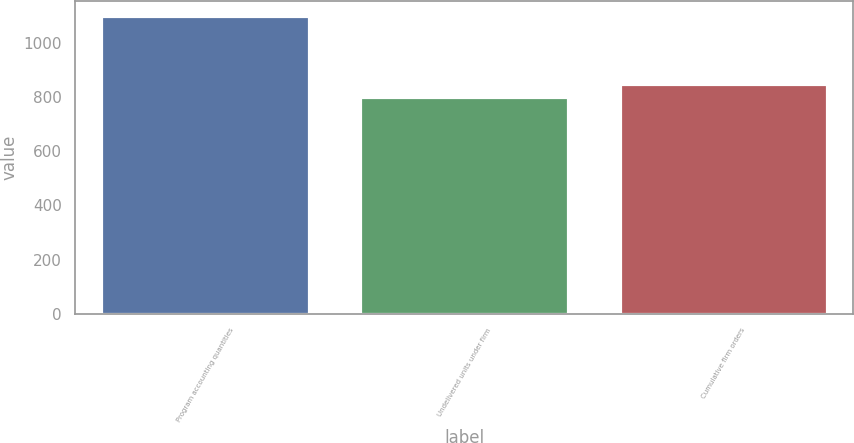<chart> <loc_0><loc_0><loc_500><loc_500><bar_chart><fcel>Program accounting quantities<fcel>Undelivered units under firm<fcel>Cumulative firm orders<nl><fcel>1100<fcel>799<fcel>848<nl></chart> 